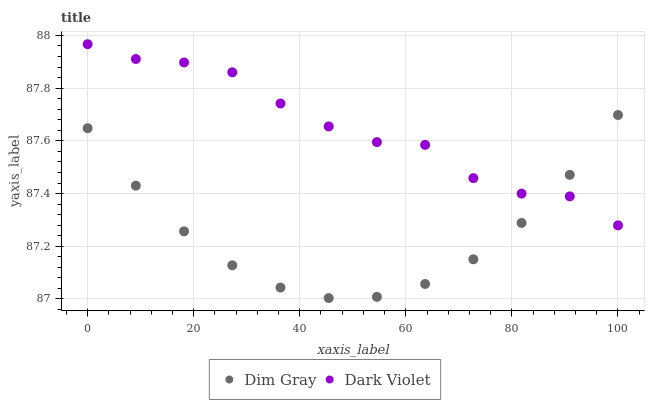Does Dim Gray have the minimum area under the curve?
Answer yes or no. Yes. Does Dark Violet have the maximum area under the curve?
Answer yes or no. Yes. Does Dark Violet have the minimum area under the curve?
Answer yes or no. No. Is Dim Gray the smoothest?
Answer yes or no. Yes. Is Dark Violet the roughest?
Answer yes or no. Yes. Is Dark Violet the smoothest?
Answer yes or no. No. Does Dim Gray have the lowest value?
Answer yes or no. Yes. Does Dark Violet have the lowest value?
Answer yes or no. No. Does Dark Violet have the highest value?
Answer yes or no. Yes. Does Dark Violet intersect Dim Gray?
Answer yes or no. Yes. Is Dark Violet less than Dim Gray?
Answer yes or no. No. Is Dark Violet greater than Dim Gray?
Answer yes or no. No. 